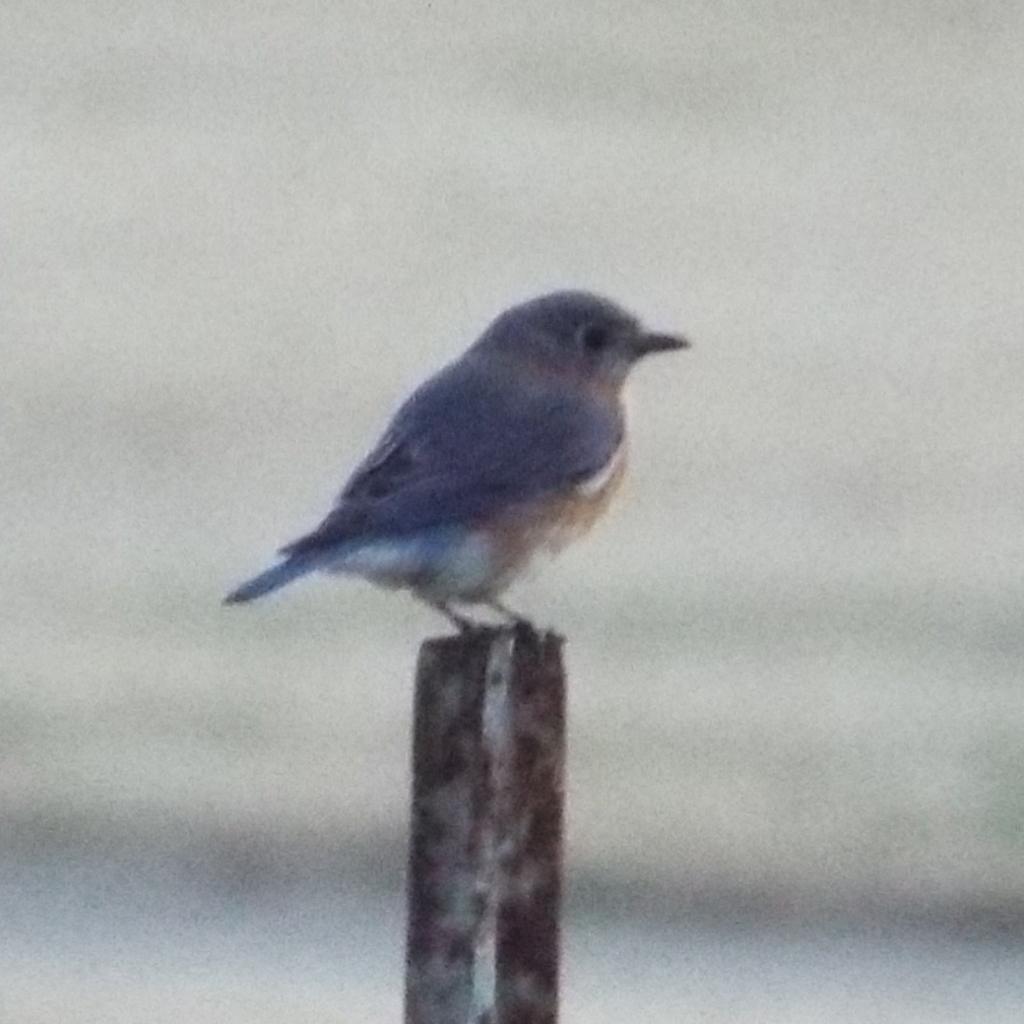In one or two sentences, can you explain what this image depicts? In the middle of the image we can see a bird and blurry background. 